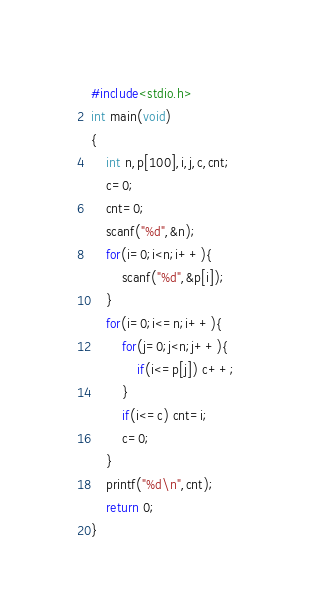<code> <loc_0><loc_0><loc_500><loc_500><_C_>#include<stdio.h>
int main(void)
{
	int n,p[100],i,j,c,cnt;
	c=0;
	cnt=0;
	scanf("%d",&n);
	for(i=0;i<n;i++){
		scanf("%d",&p[i]);
	}
	for(i=0;i<=n;i++){
		for(j=0;j<n;j++){
			if(i<=p[j]) c++;
		}
		if(i<=c) cnt=i;
		c=0;
	}
	printf("%d\n",cnt);
	return 0;
}
</code> 